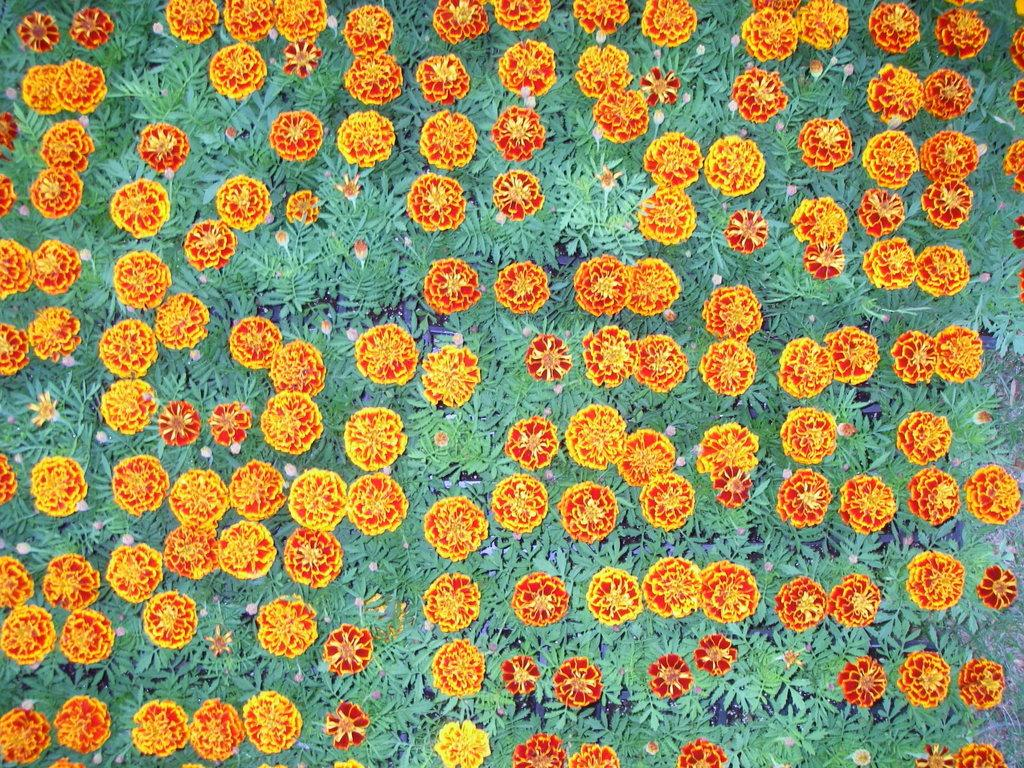What is on the cloth in the image? There is a painting on the cloth in the image. What does the painting depict? The painting depicts buds, flowers, and plants. What type of plants are shown in the painting? The painting depicts flowers and buds, which are both types of plants. How many children are playing near the gate in the image? There is no gate or children present in the image; it only features a painting on a cloth. 